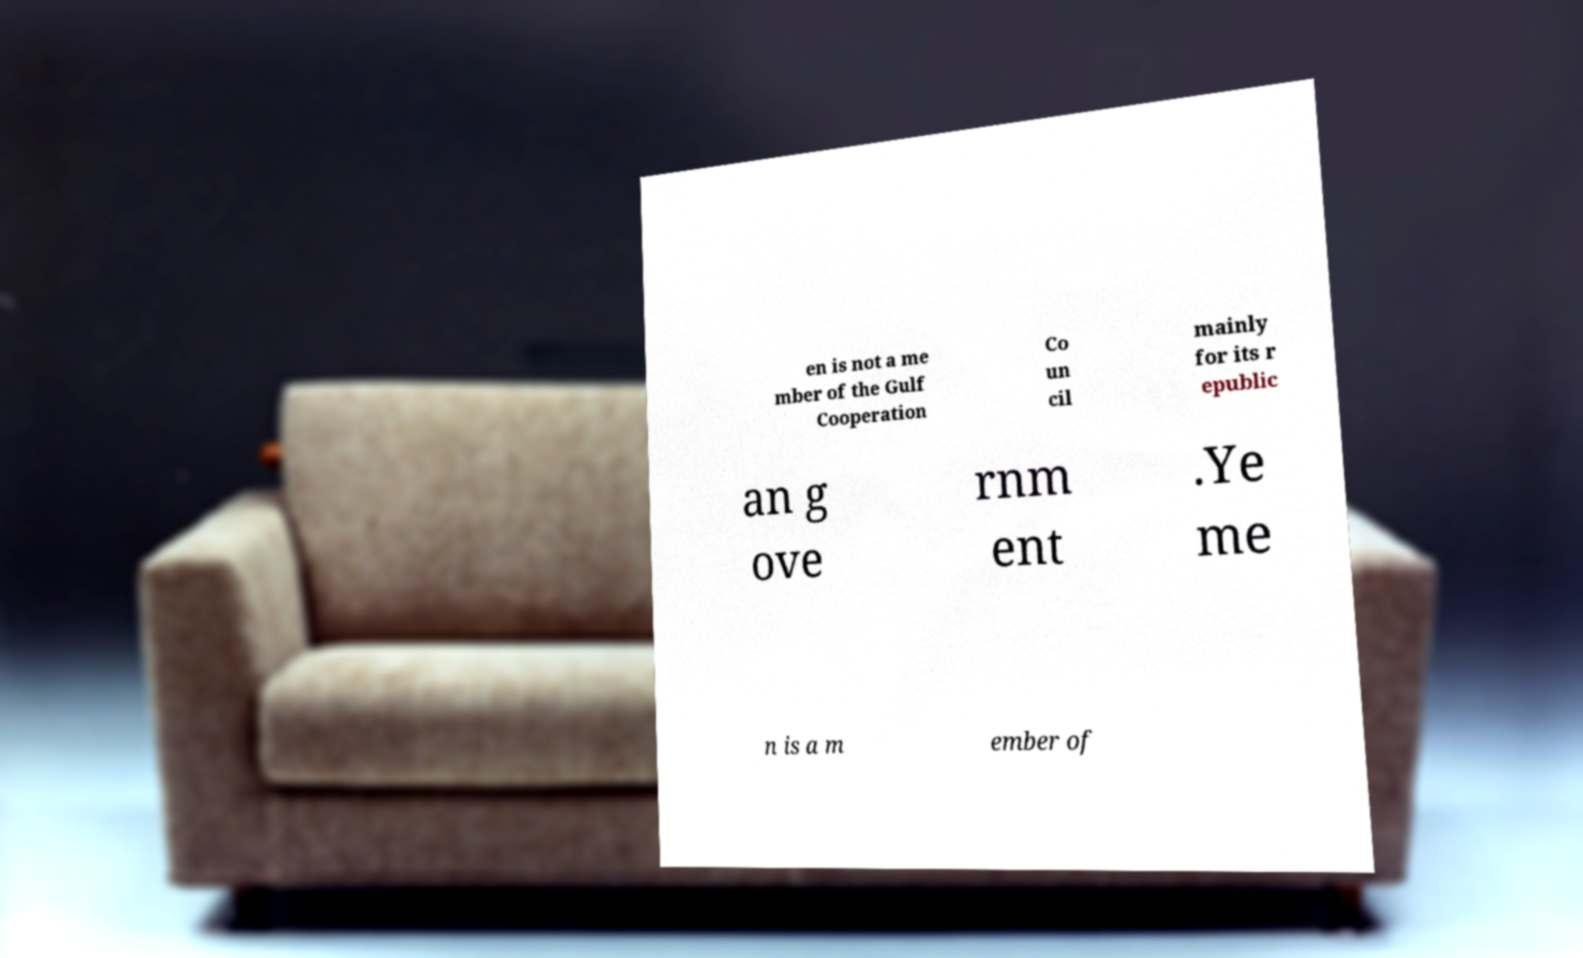I need the written content from this picture converted into text. Can you do that? en is not a me mber of the Gulf Cooperation Co un cil mainly for its r epublic an g ove rnm ent .Ye me n is a m ember of 